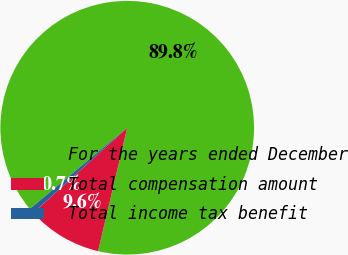Convert chart. <chart><loc_0><loc_0><loc_500><loc_500><pie_chart><fcel>For the years ended December<fcel>Total compensation amount<fcel>Total income tax benefit<nl><fcel>89.75%<fcel>9.58%<fcel>0.67%<nl></chart> 